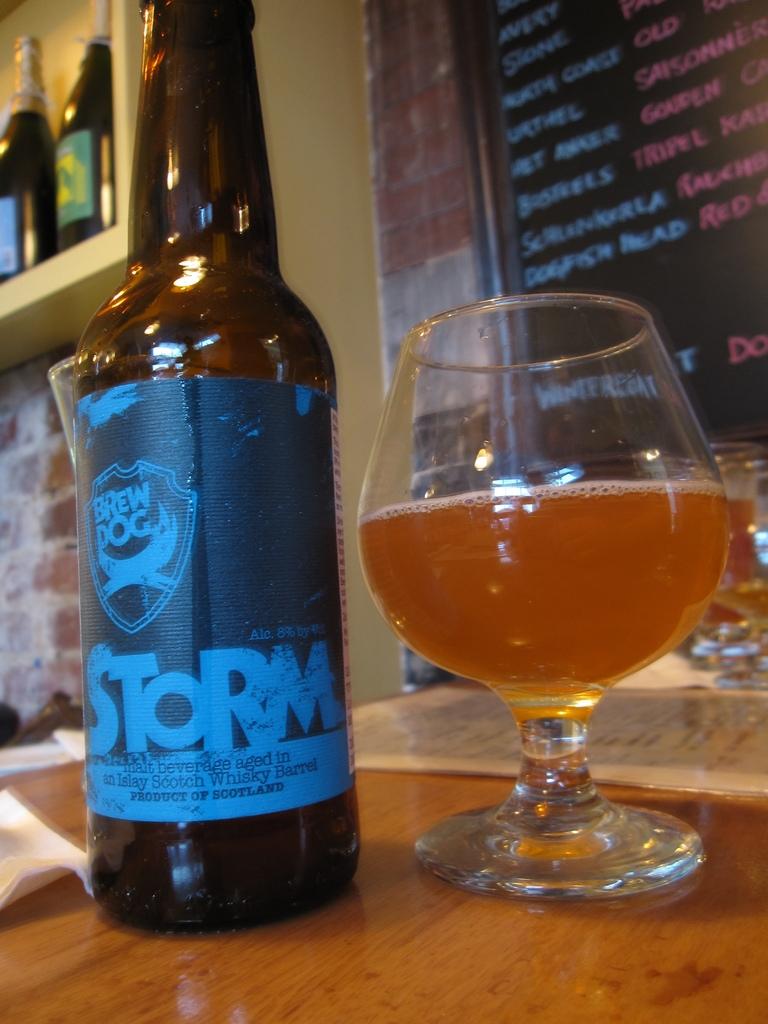What are the two words above the name of the beer?
Provide a succinct answer. Brew dog. 